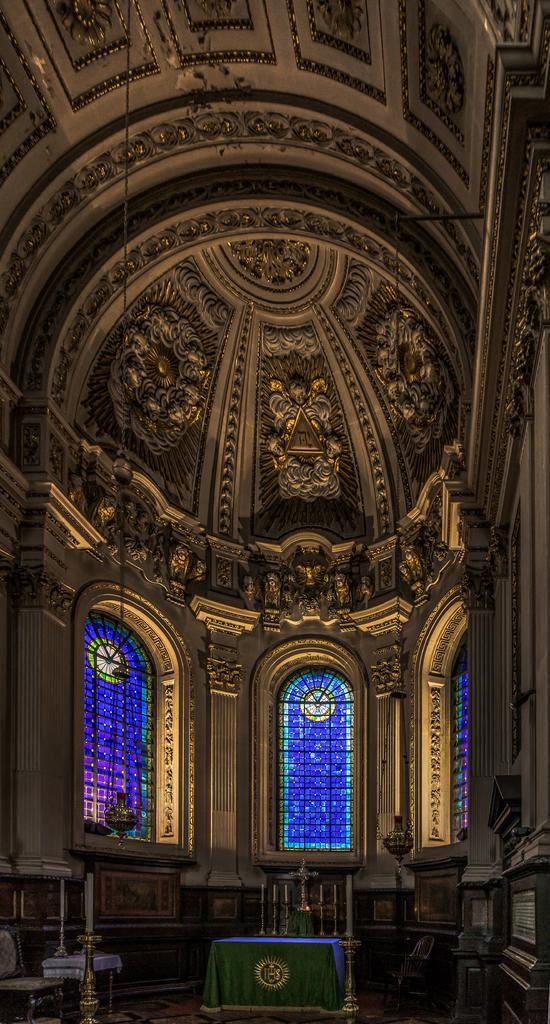What type of location is depicted in the image? The image shows an inside view of a building. What can be seen in the background of the image? There are glass windows visible in the background. What is present at the bottom of the image? There are objects or features present at the bottom of the image. Can you describe the flock of birds attacking the building in the image? There is no flock of birds attacking the building in the image; it shows an inside view of a building with glass windows in the background. 